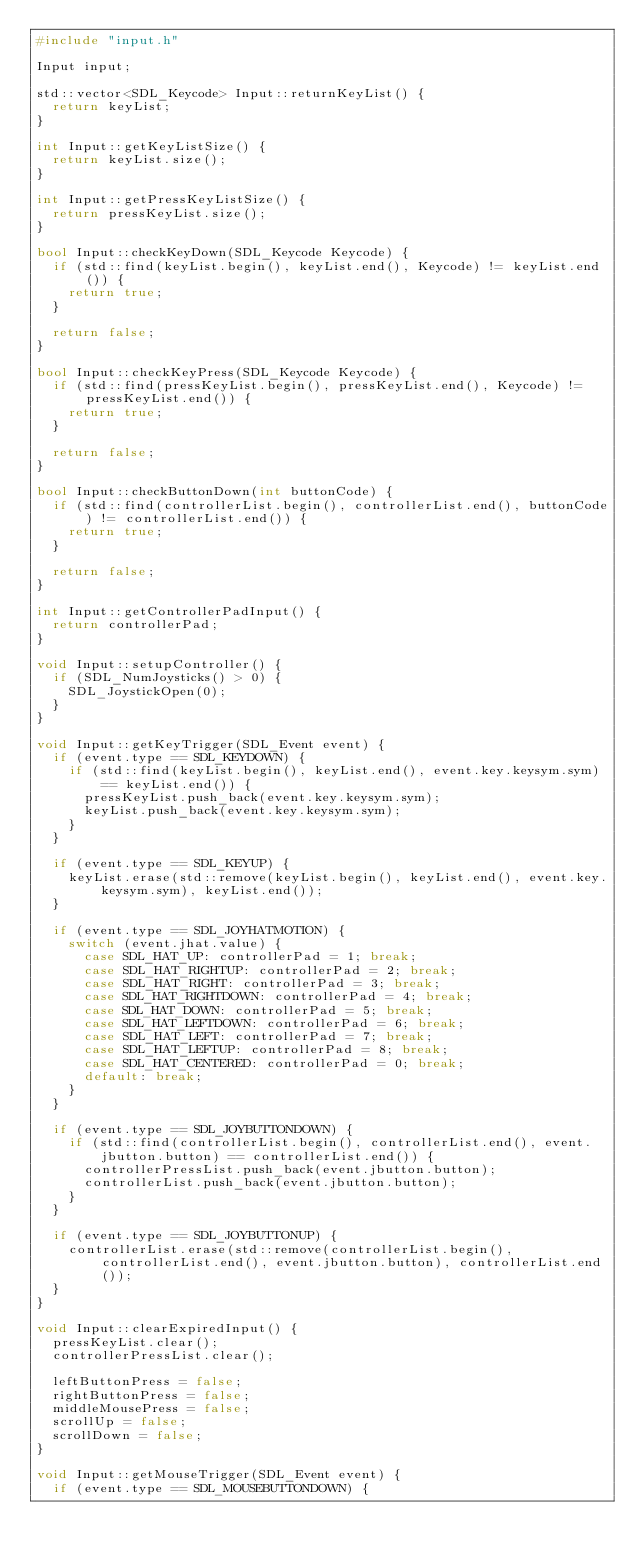<code> <loc_0><loc_0><loc_500><loc_500><_C++_>#include "input.h"

Input input;

std::vector<SDL_Keycode> Input::returnKeyList() {
	return keyList;
}

int Input::getKeyListSize() {
	return keyList.size();
}

int Input::getPressKeyListSize() {
	return pressKeyList.size();
}

bool Input::checkKeyDown(SDL_Keycode Keycode) {
	if (std::find(keyList.begin(), keyList.end(), Keycode) != keyList.end()) {
		return true;
	}

	return false;
}

bool Input::checkKeyPress(SDL_Keycode Keycode) {
	if (std::find(pressKeyList.begin(), pressKeyList.end(), Keycode) != pressKeyList.end()) {
		return true;
	}

	return false;
}

bool Input::checkButtonDown(int buttonCode) {
	if (std::find(controllerList.begin(), controllerList.end(), buttonCode) != controllerList.end()) {
		return true;
	}

	return false;
}

int Input::getControllerPadInput() {
	return controllerPad;
}

void Input::setupController() {
	if (SDL_NumJoysticks() > 0) {
		SDL_JoystickOpen(0);
	}
}

void Input::getKeyTrigger(SDL_Event event) {
	if (event.type == SDL_KEYDOWN) {
		if (std::find(keyList.begin(), keyList.end(), event.key.keysym.sym) == keyList.end()) {
			pressKeyList.push_back(event.key.keysym.sym);
			keyList.push_back(event.key.keysym.sym);
		}
	}

	if (event.type == SDL_KEYUP) {
		keyList.erase(std::remove(keyList.begin(), keyList.end(), event.key.keysym.sym), keyList.end());
	}

	if (event.type == SDL_JOYHATMOTION) {
		switch (event.jhat.value) {
			case SDL_HAT_UP: controllerPad = 1; break;
			case SDL_HAT_RIGHTUP: controllerPad = 2; break;
			case SDL_HAT_RIGHT: controllerPad = 3; break;
			case SDL_HAT_RIGHTDOWN: controllerPad = 4; break;
			case SDL_HAT_DOWN: controllerPad = 5; break;
			case SDL_HAT_LEFTDOWN: controllerPad = 6; break;
			case SDL_HAT_LEFT: controllerPad = 7; break;
			case SDL_HAT_LEFTUP: controllerPad = 8; break;
			case SDL_HAT_CENTERED: controllerPad = 0; break;
			default: break;
		}
	}

	if (event.type == SDL_JOYBUTTONDOWN) {
		if (std::find(controllerList.begin(), controllerList.end(), event.jbutton.button) == controllerList.end()) {
			controllerPressList.push_back(event.jbutton.button);
			controllerList.push_back(event.jbutton.button);
		}
	}

	if (event.type == SDL_JOYBUTTONUP) {
		controllerList.erase(std::remove(controllerList.begin(), controllerList.end(), event.jbutton.button), controllerList.end());
	}
}

void Input::clearExpiredInput() {
	pressKeyList.clear();
	controllerPressList.clear();

	leftButtonPress = false;
	rightButtonPress = false;
	middleMousePress = false;
	scrollUp = false;
	scrollDown = false;
}

void Input::getMouseTrigger(SDL_Event event) {
	if (event.type == SDL_MOUSEBUTTONDOWN) {</code> 